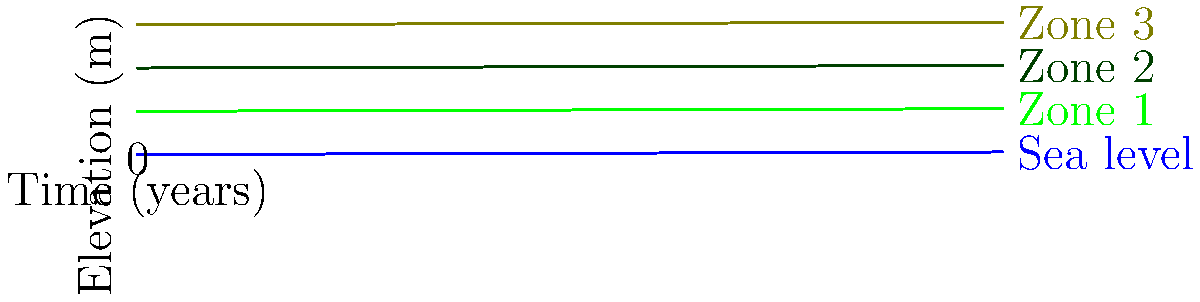Based on the graph showing sea level rise and coastal vegetation zones over time, calculate the rate at which the width of Zone 1 is changing. Express your answer in meters per year. To determine the rate at which the width of Zone 1 is changing, we need to follow these steps:

1. Observe that Zone 1 is bounded by the sea level line at the bottom and the Zone 2 line at the top.

2. Note that both the sea level and all vegetation zones are rising at the same rate.

3. Calculate the elevation difference between Zone 1 and sea level:
   At t = 0: Zone 1 elevation = 5 m, Sea level = 0 m
   Difference = 5 m - 0 m = 5 m

4. Calculate the elevation difference between Zone 2 and sea level:
   At t = 0: Zone 2 elevation = 10 m, Sea level = 0 m
   Difference = 10 m - 0 m = 10 m

5. The width of Zone 1 is the difference between these two values:
   Width of Zone 1 = 10 m - 5 m = 5 m

6. Observe that this width remains constant over time because all lines are rising at the same rate.

7. Since the width is not changing, the rate of change is 0 meters per year.
Answer: 0 m/year 